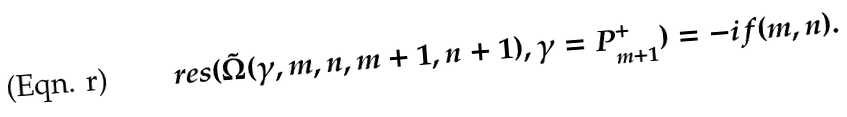<formula> <loc_0><loc_0><loc_500><loc_500>\ r e s ( \tilde { \Omega } ( \gamma , m , n , m + 1 , n + 1 ) , \gamma = P ^ { + } _ { m + 1 } ) = - i f ( m , n ) .</formula> 